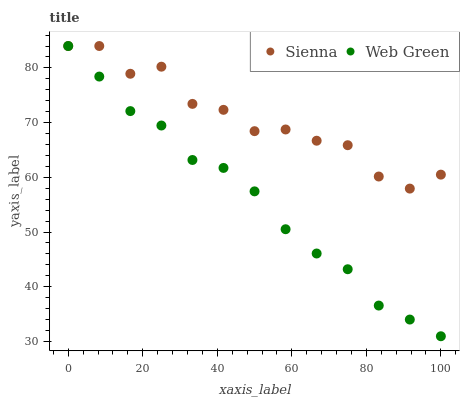Does Web Green have the minimum area under the curve?
Answer yes or no. Yes. Does Sienna have the maximum area under the curve?
Answer yes or no. Yes. Does Web Green have the maximum area under the curve?
Answer yes or no. No. Is Web Green the smoothest?
Answer yes or no. Yes. Is Sienna the roughest?
Answer yes or no. Yes. Is Web Green the roughest?
Answer yes or no. No. Does Web Green have the lowest value?
Answer yes or no. Yes. Does Web Green have the highest value?
Answer yes or no. Yes. Does Web Green intersect Sienna?
Answer yes or no. Yes. Is Web Green less than Sienna?
Answer yes or no. No. Is Web Green greater than Sienna?
Answer yes or no. No. 